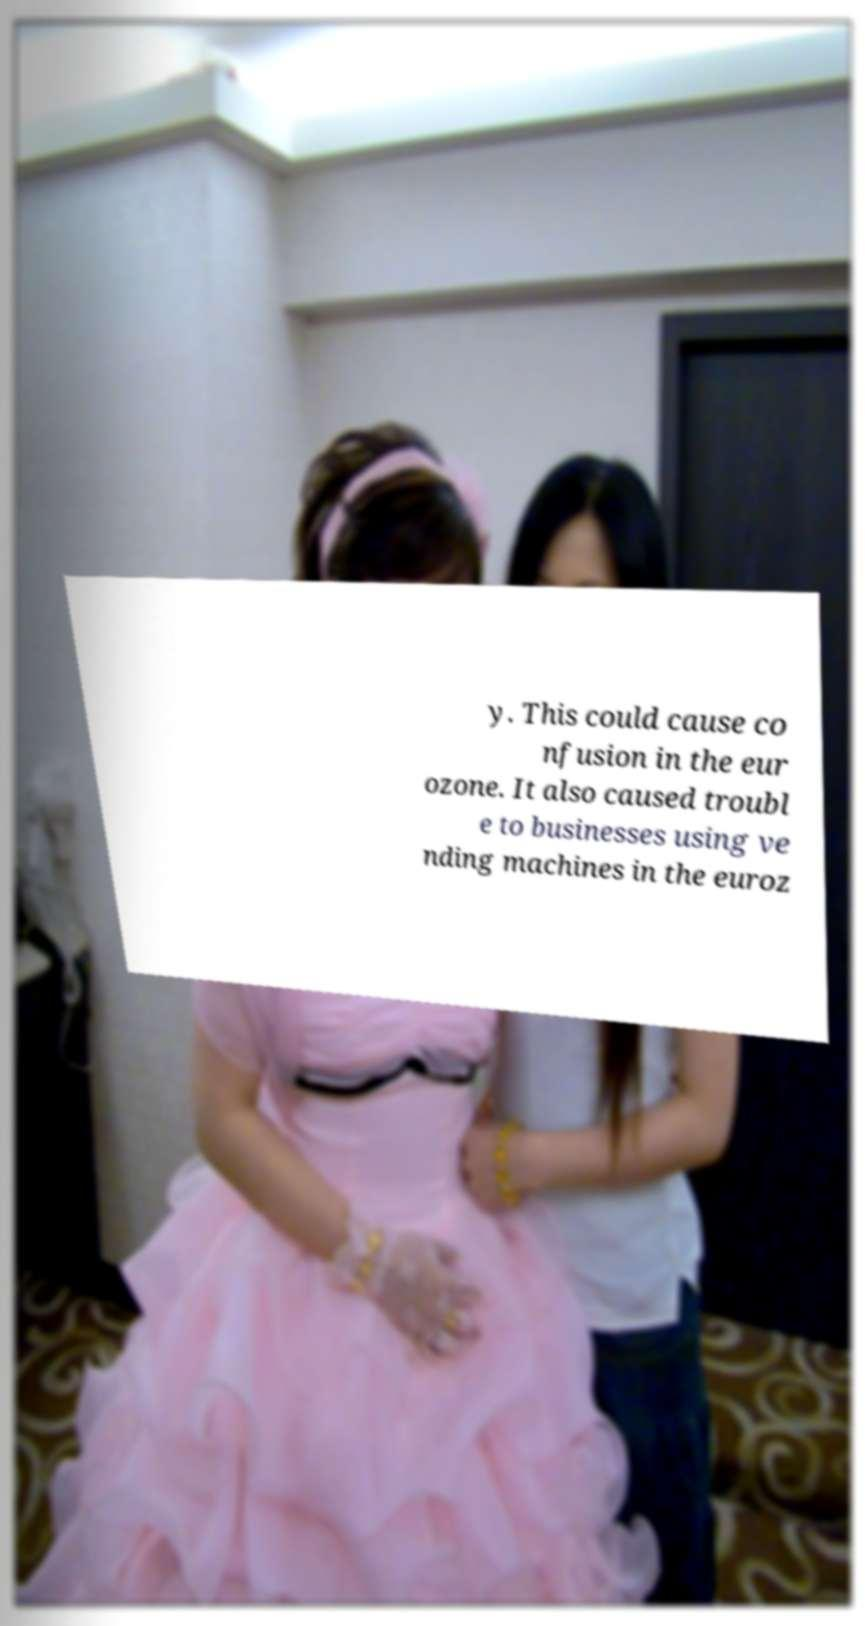Could you assist in decoding the text presented in this image and type it out clearly? y. This could cause co nfusion in the eur ozone. It also caused troubl e to businesses using ve nding machines in the euroz 